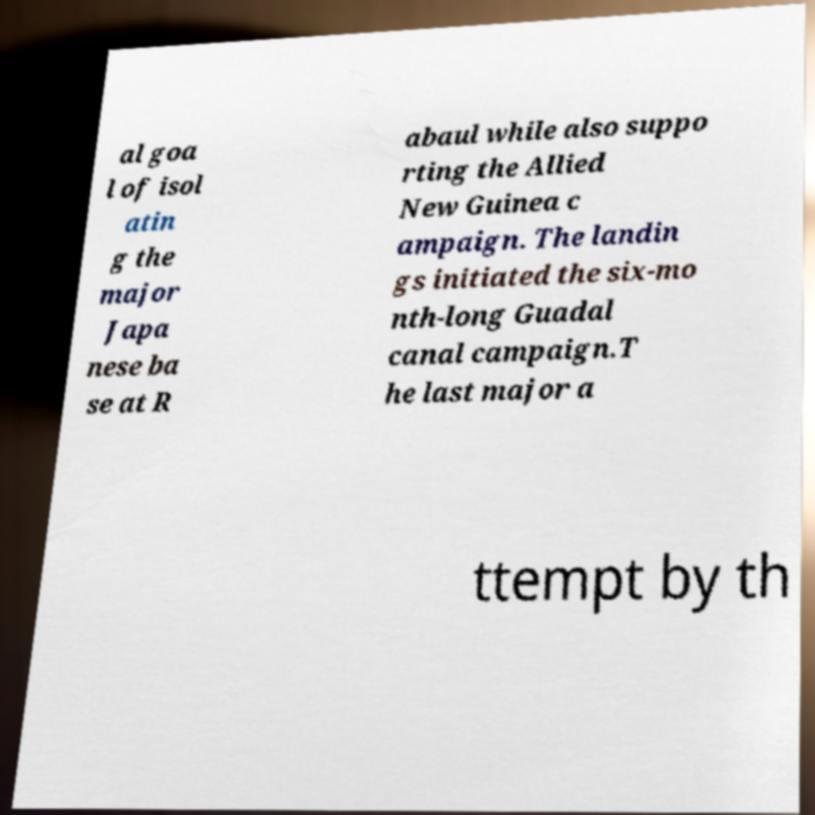For documentation purposes, I need the text within this image transcribed. Could you provide that? al goa l of isol atin g the major Japa nese ba se at R abaul while also suppo rting the Allied New Guinea c ampaign. The landin gs initiated the six-mo nth-long Guadal canal campaign.T he last major a ttempt by th 